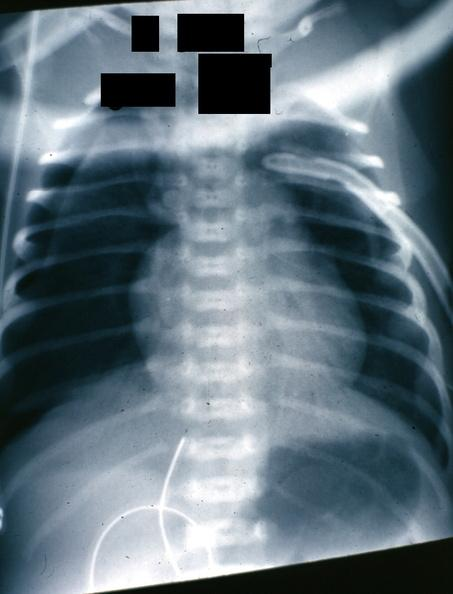s pneumothorax x-ray infant present?
Answer the question using a single word or phrase. Yes 